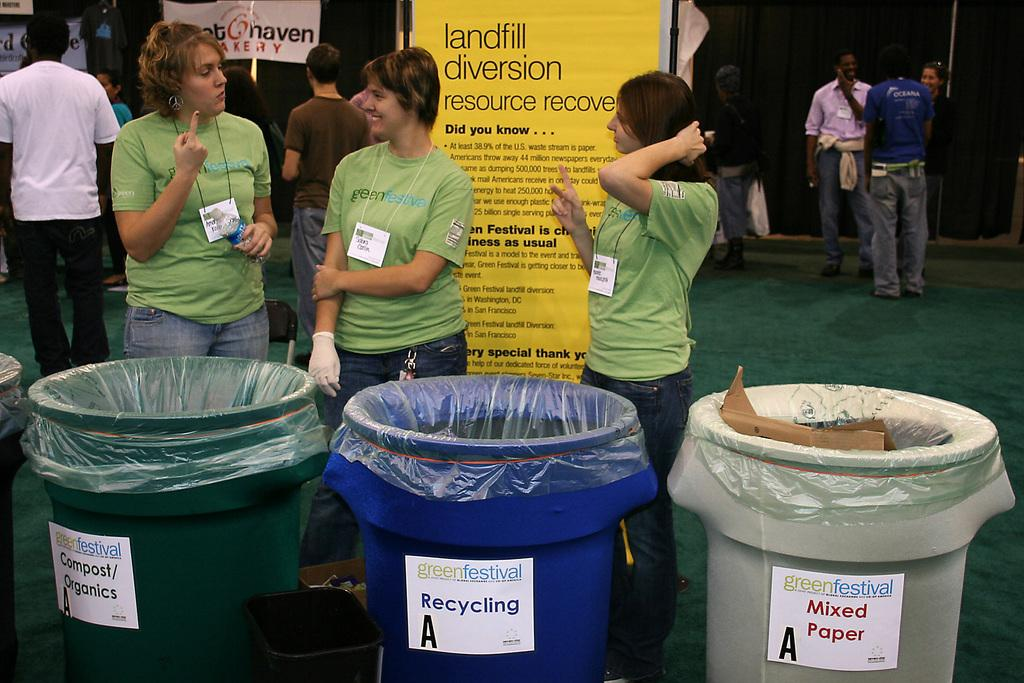Provide a one-sentence caption for the provided image. Landfill Diversion resource recovery is a sign pictured about recycling. 